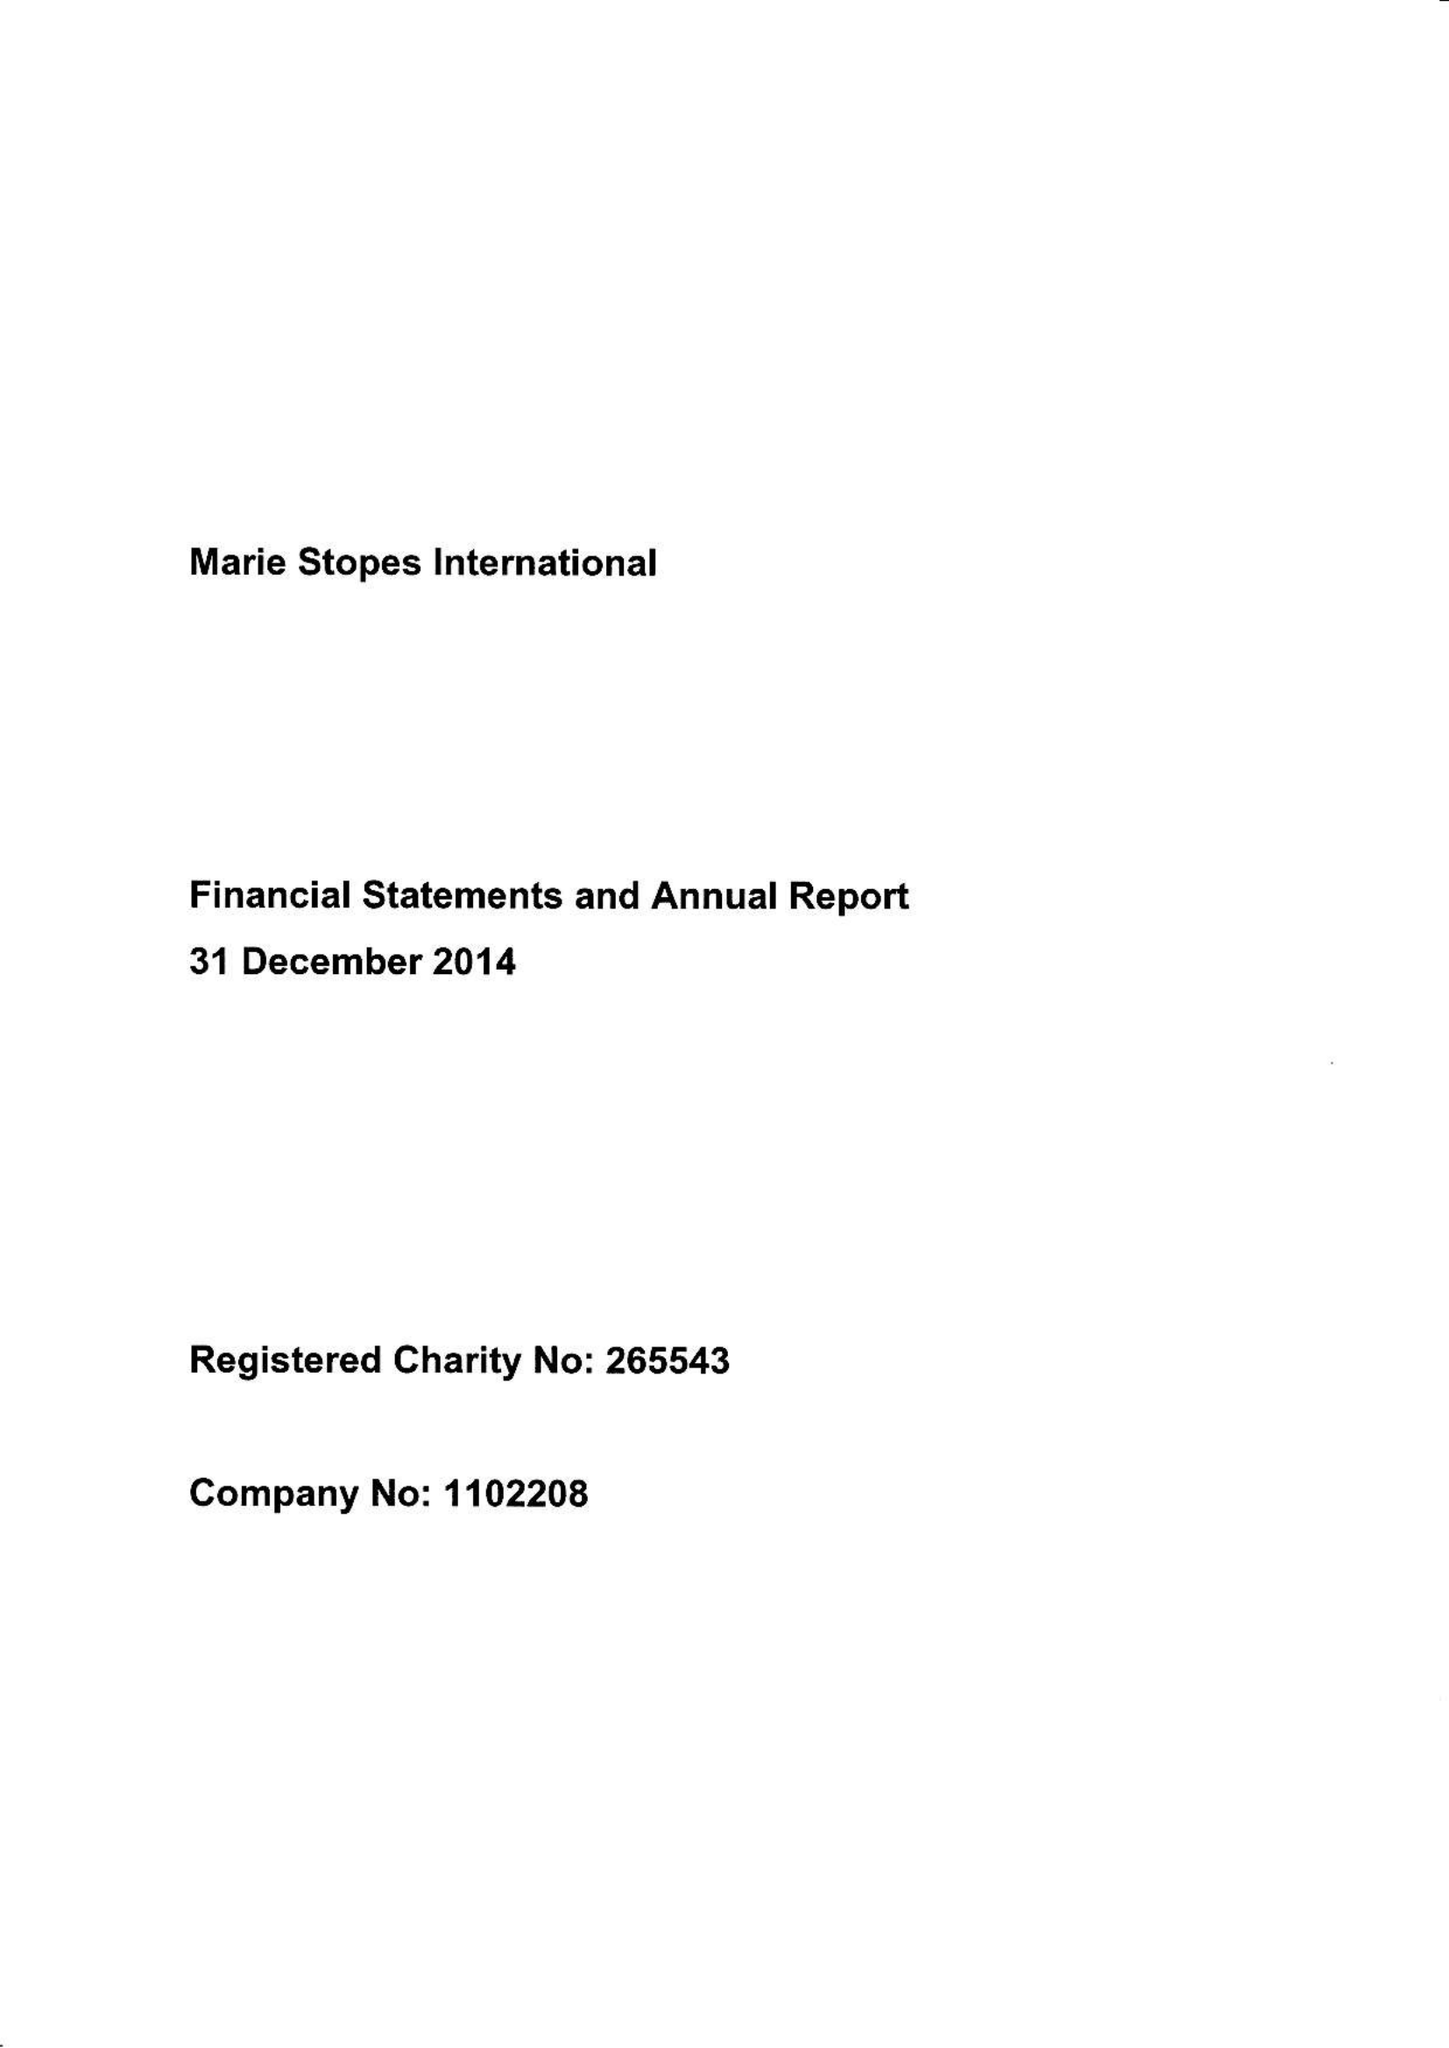What is the value for the charity_number?
Answer the question using a single word or phrase. 265543 